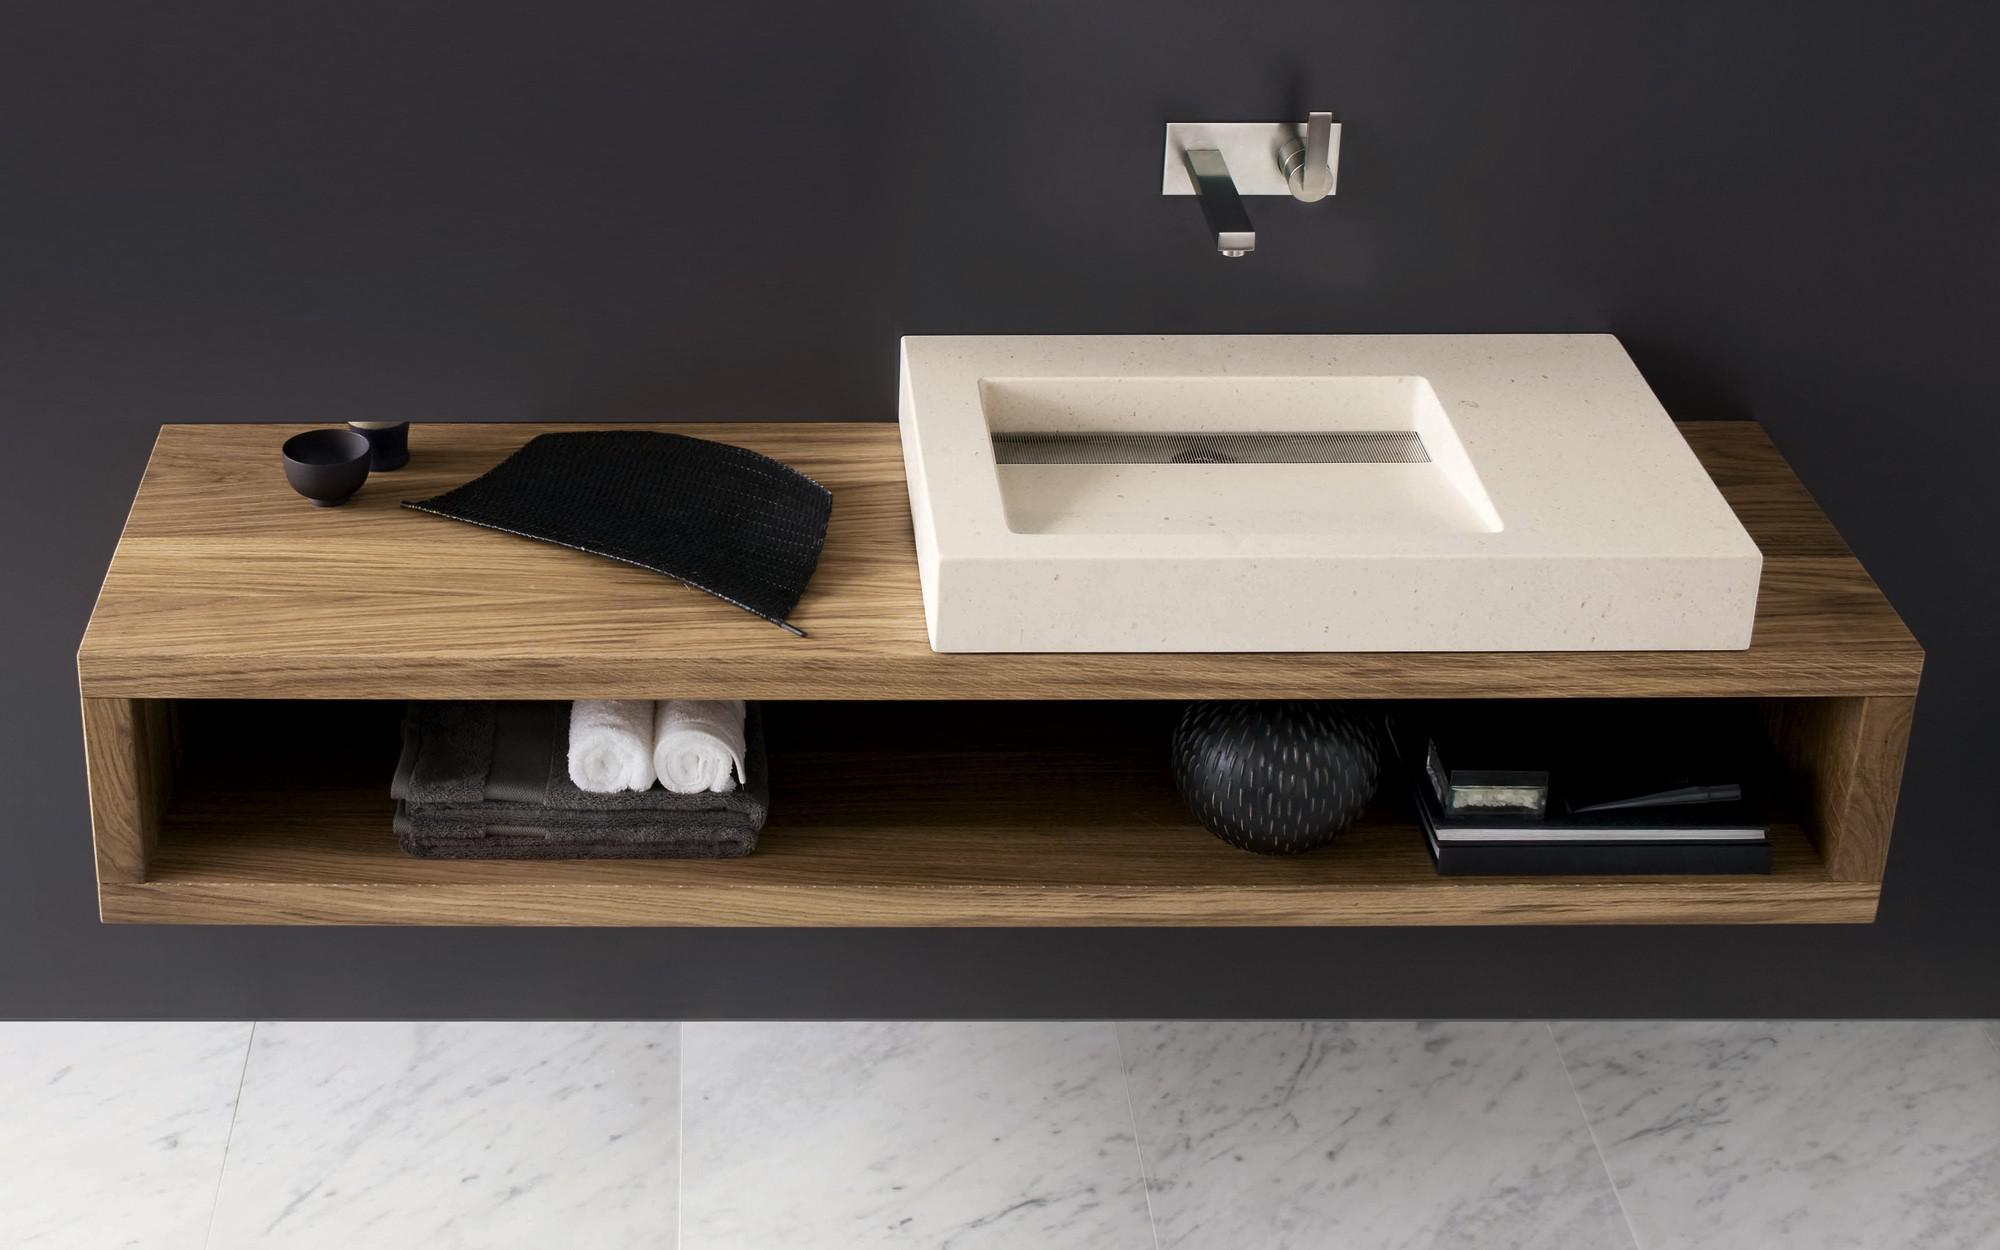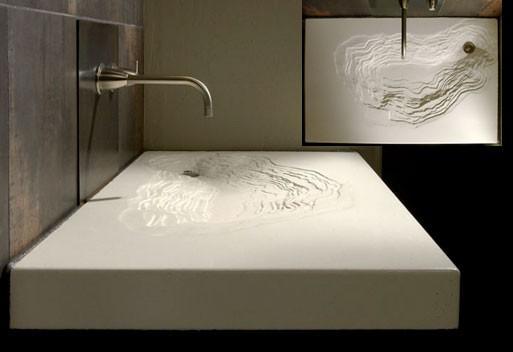The first image is the image on the left, the second image is the image on the right. Given the left and right images, does the statement "A mirror sits behind the sink in each of the images." hold true? Answer yes or no. No. The first image is the image on the left, the second image is the image on the right. For the images shown, is this caption "All sinks shown sit on top of a vanity, at least some vanities have wood grain, and white towels are underneath at least one vanity." true? Answer yes or no. No. 